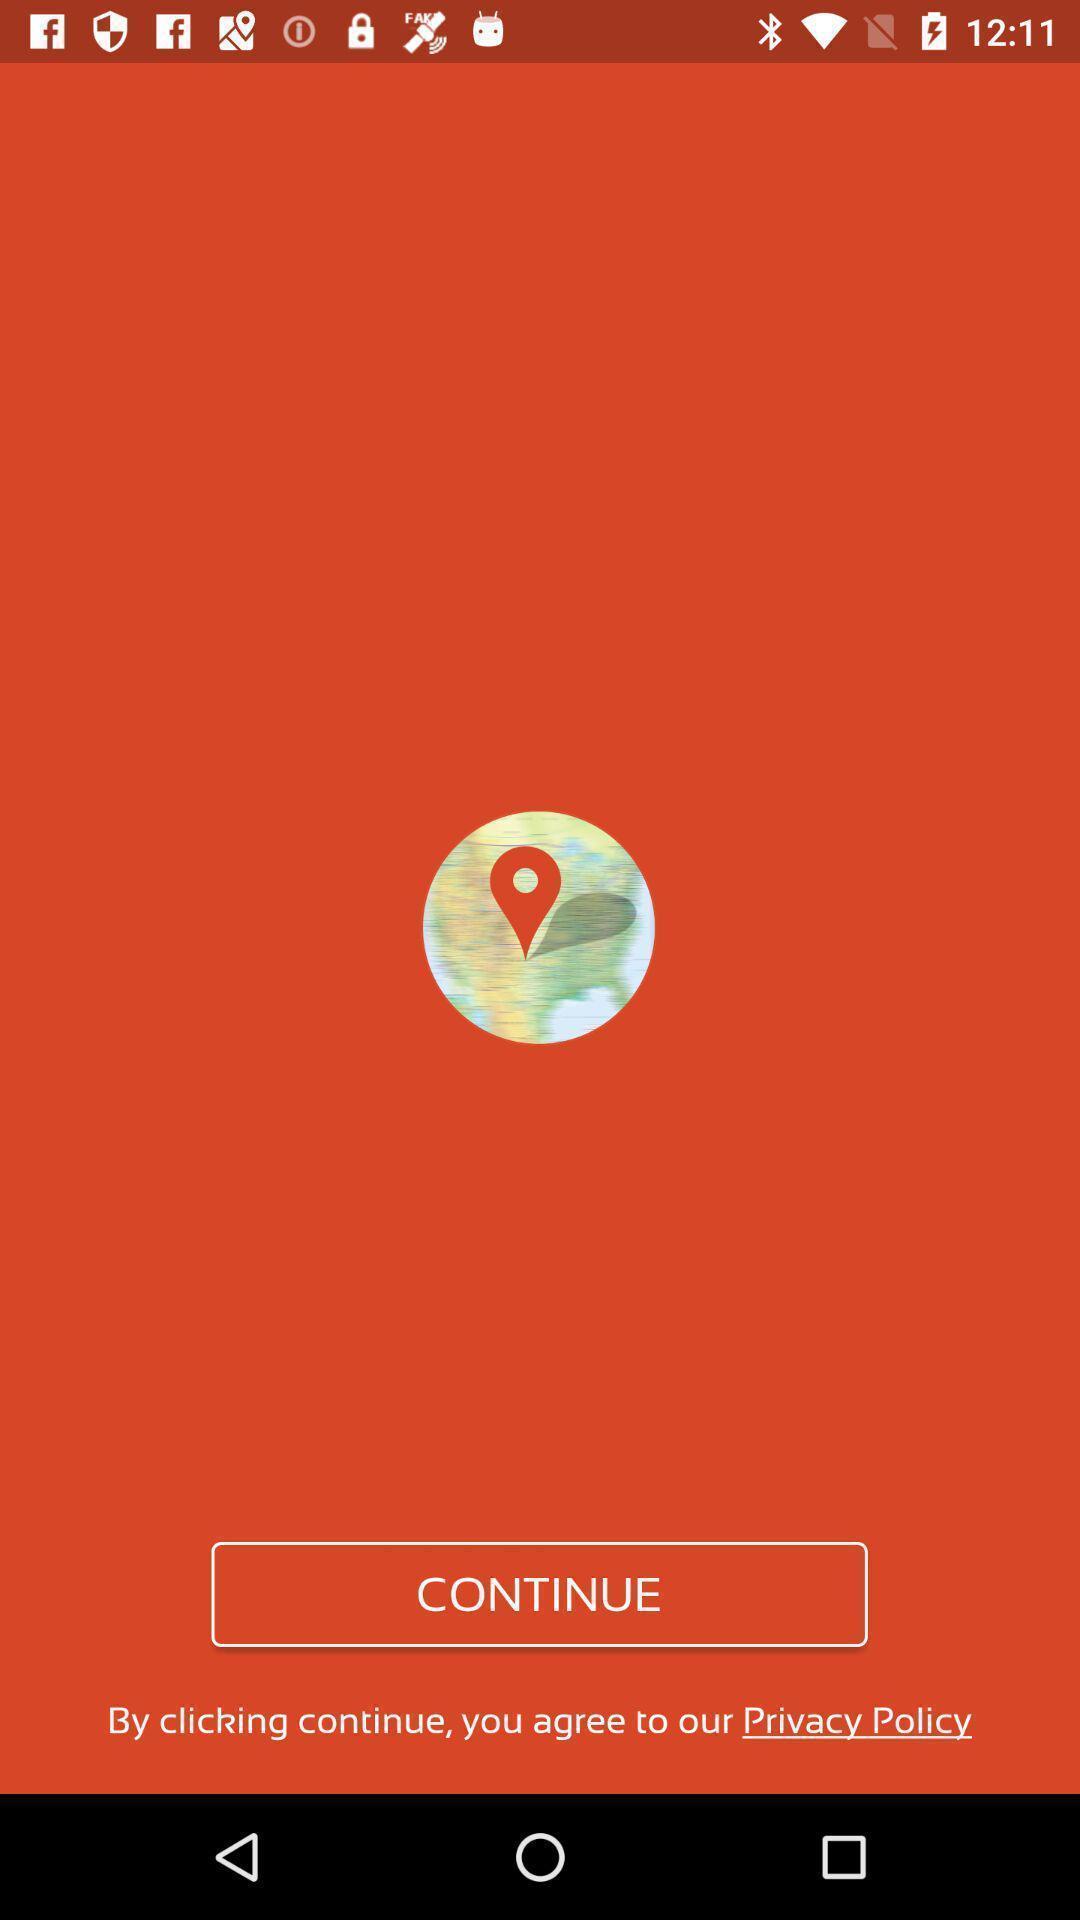Describe the key features of this screenshot. Welcome page. 